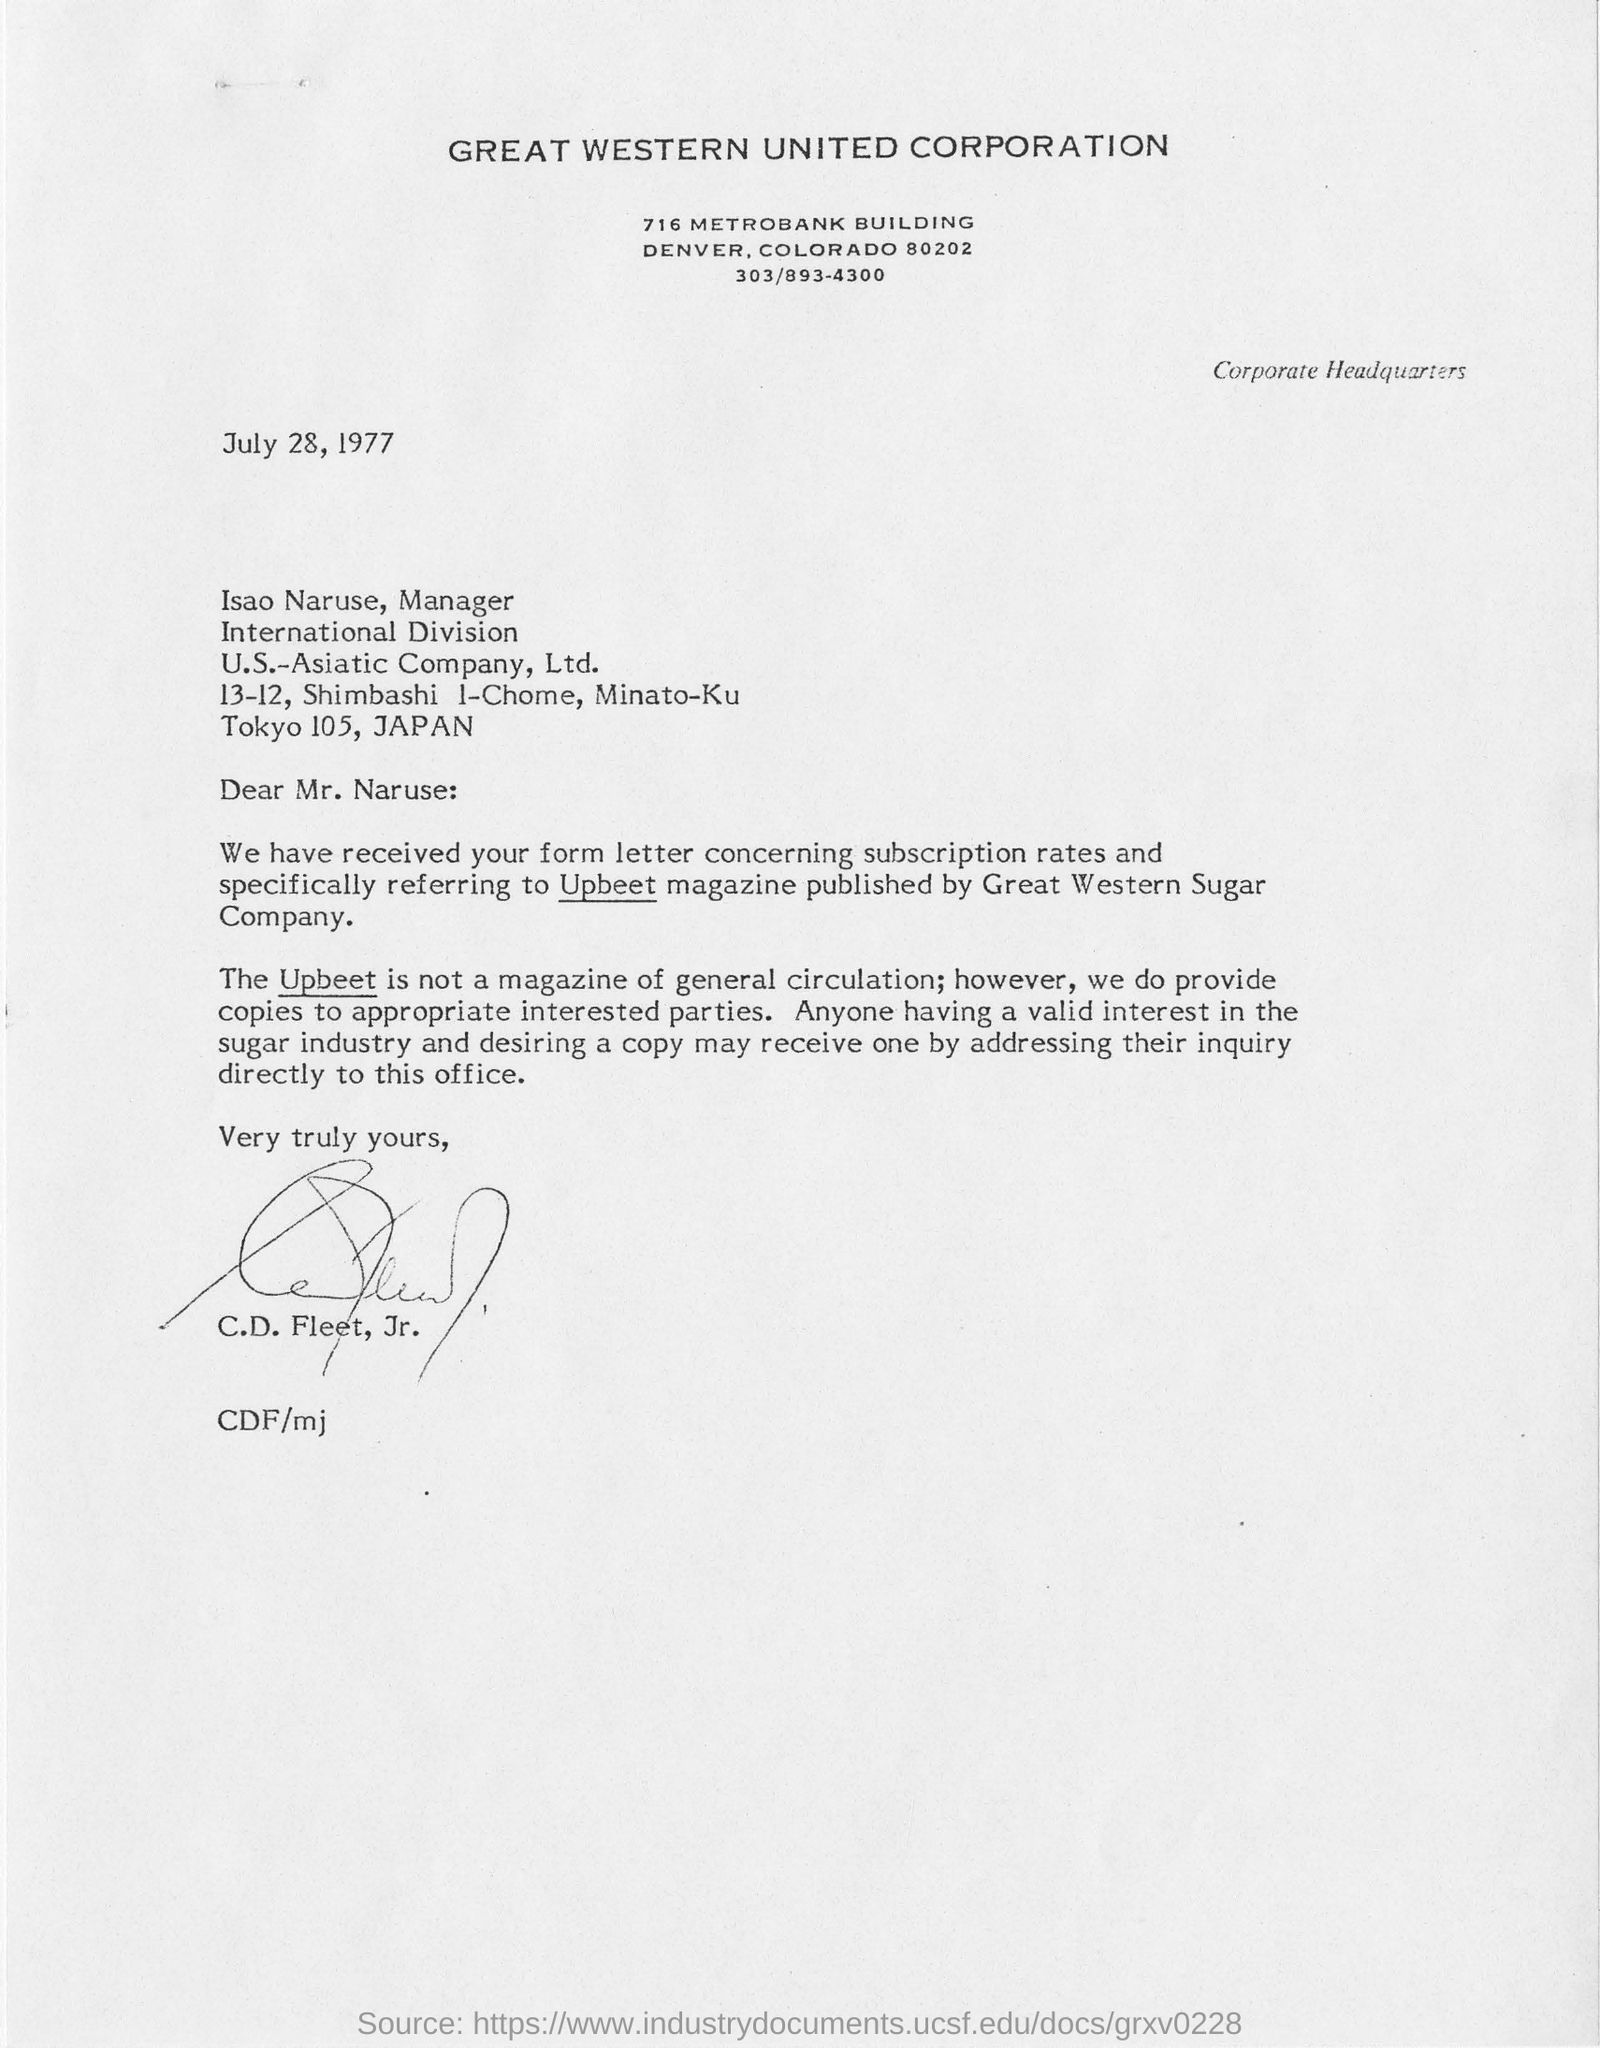Which state is the Great Western United Corporation located?
Your answer should be compact. Colorado. When is the letter dated?
Your response must be concise. July 28, 1977. Who is the letter addressed to?
Make the answer very short. Isao Naruse, Manager. Isao Naruse is the manager of which company?
Ensure brevity in your answer.  U.S.-Asiatic Company, Ltd. What is the name of magazine published by Great Western Sugar Company?
Offer a very short reply. Upbeet. In which country is the U.S-Asiatic Company Ltd. located?
Provide a short and direct response. Japan. 